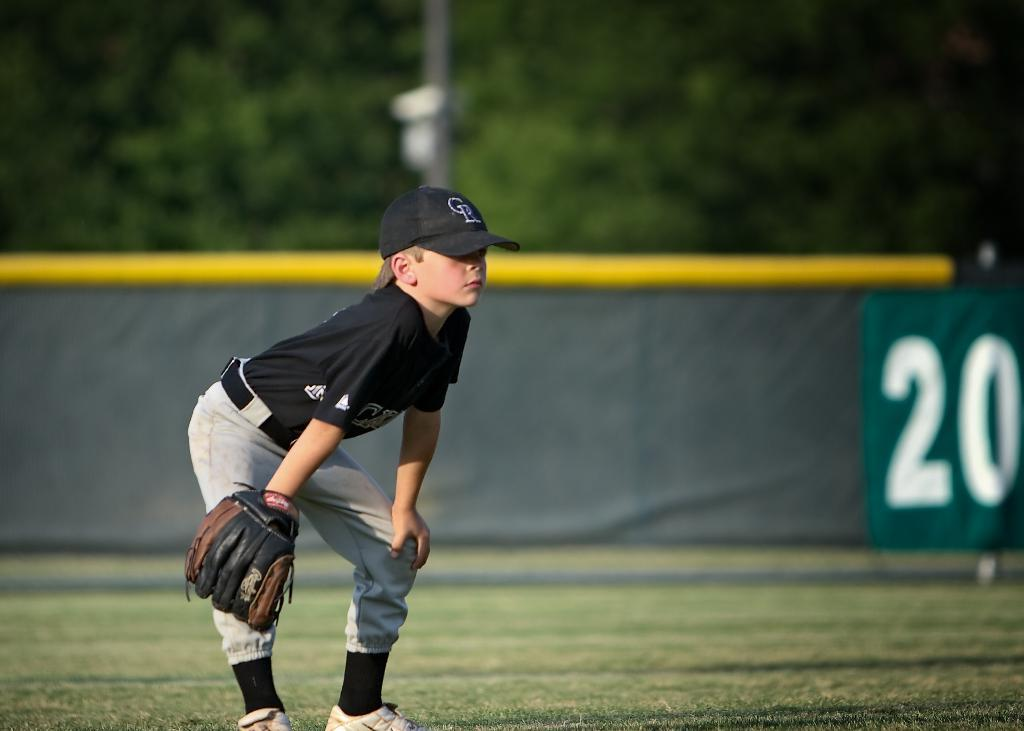<image>
Describe the image concisely. A young baseball player is watching for a catch near a sign that says 20. 